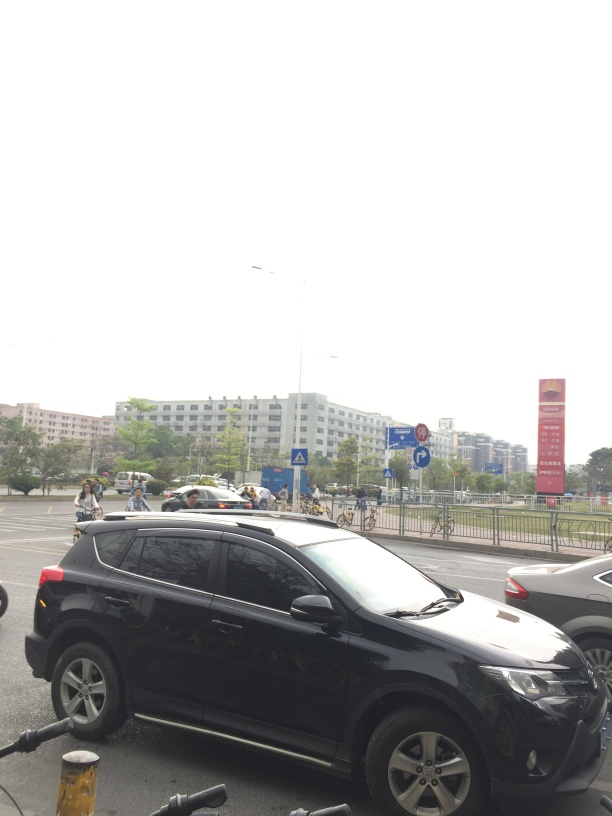What kind of weather does it seem to be in the image? The weather in the image looks overcast with diffused natural light, indicating it could be a cloudy day. There are no sharp shadows, which supports the absence of direct sunlight. The overall brightness despite the cloudiness suggests it might be the middle part of the day. 